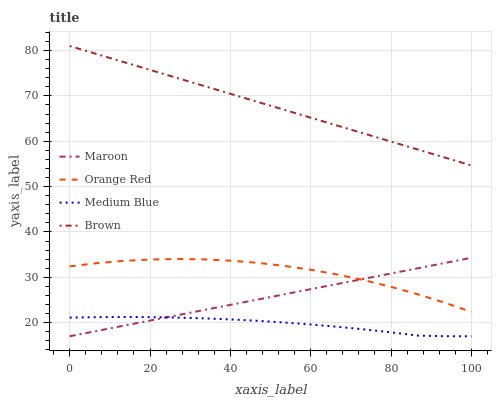Does Medium Blue have the minimum area under the curve?
Answer yes or no. Yes. Does Brown have the maximum area under the curve?
Answer yes or no. Yes. Does Orange Red have the minimum area under the curve?
Answer yes or no. No. Does Orange Red have the maximum area under the curve?
Answer yes or no. No. Is Maroon the smoothest?
Answer yes or no. Yes. Is Orange Red the roughest?
Answer yes or no. Yes. Is Medium Blue the smoothest?
Answer yes or no. No. Is Medium Blue the roughest?
Answer yes or no. No. Does Medium Blue have the lowest value?
Answer yes or no. Yes. Does Orange Red have the lowest value?
Answer yes or no. No. Does Brown have the highest value?
Answer yes or no. Yes. Does Orange Red have the highest value?
Answer yes or no. No. Is Medium Blue less than Orange Red?
Answer yes or no. Yes. Is Brown greater than Maroon?
Answer yes or no. Yes. Does Maroon intersect Medium Blue?
Answer yes or no. Yes. Is Maroon less than Medium Blue?
Answer yes or no. No. Is Maroon greater than Medium Blue?
Answer yes or no. No. Does Medium Blue intersect Orange Red?
Answer yes or no. No. 